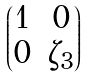<formula> <loc_0><loc_0><loc_500><loc_500>\begin{pmatrix} 1 & 0 \\ 0 & \zeta _ { 3 } \end{pmatrix}</formula> 